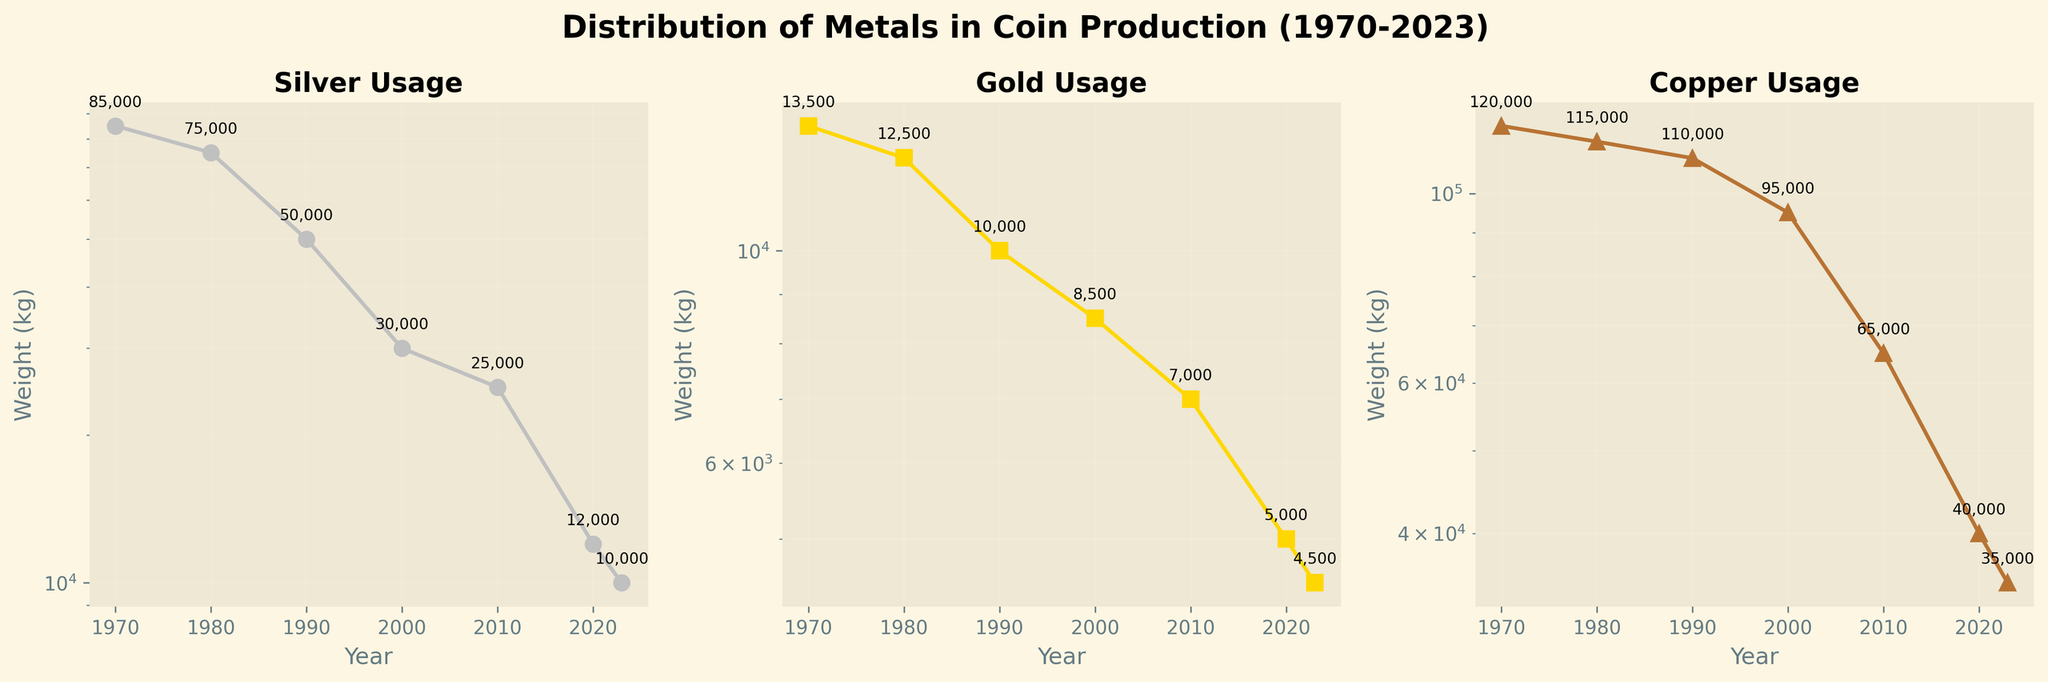What is the title of the figure? The title of the figure is located at the top center and provides a general overview. It reads, "Distribution of Metals in Coin Production (1970-2023)"
Answer: Distribution of Metals in Coin Production (1970-2023) Which metal has the highest usage in 1970? Each subplot represents a metal and includes data points with annotations for each year. In 1970, the labels indicate that copper has the highest usage, annotated as 120,000 kg.
Answer: Copper What is the trend of gold usage from 1970 to 2023? Observing the Gold Usage subplot, we see a consistent downward trend from 13,500 kg in 1970 to 4,500 kg in 2023.
Answer: Downward In what year did the usage of silver drop below 30,000 kg? In the Silver Usage subplot, look for the data points around the value 30,000 kg. It drops below this value between the years 1990 and 2000. The 2000 annotation is 30,000, implying it dropped below in 2010.
Answer: 2010 Which year shows the largest decrease in copper usage and by how much? The Copper Usage subplot shows the annotations of 95,000 kg in 2000 down to 65,000 kg in 2010, a difference of 30,000 kg. This is the largest decrease observed.
Answer: 2000 to 2010, 30,000 kg What is the average usage of silver across all years presented? Calculating the average requires summing the silver values: 85,000 + 75,000 + 50,000 + 30,000 + 25,000 + 12,000 + 10,000 = 287,000 kg, and then dividing by the 7 data points gives 287,000/7 = 41,000 kg.
Answer: 41,000 kg How does the trend of copper usage compare to that of gold usage? Both the Copper Usage and Gold Usage subplots show decreasing trends. However, the decrease in copper is sharper between 2000-2010 while gold decreases more gradually across the entire timeframe.
Answer: Similar downward trend, copper sharper What is the ratio of silver to gold usage in 1990? The annotations for 1990 indicate silver usage of 50,000 kg and gold usage of 10,000 kg. The ratio is 50,000/10,000 = 5:1.
Answer: 5:1 When did the silver usage fall below copper usage, and by what amount? Silver usage fell below copper in 1990. In 1990, silver is 50,000 kg and copper is 110,000 kg, a difference of 110,000 - 50,000 = 60,000 kg.
Answer: 1990, 60,000 kg Which metal has the least fluctuation in usage over time? By examining the range of annotations in each subplot, gold has the least fluctuation, varying from 13,500 kg to 4,500 kg, compared to more significant fluctuations in silver and copper.
Answer: Gold 